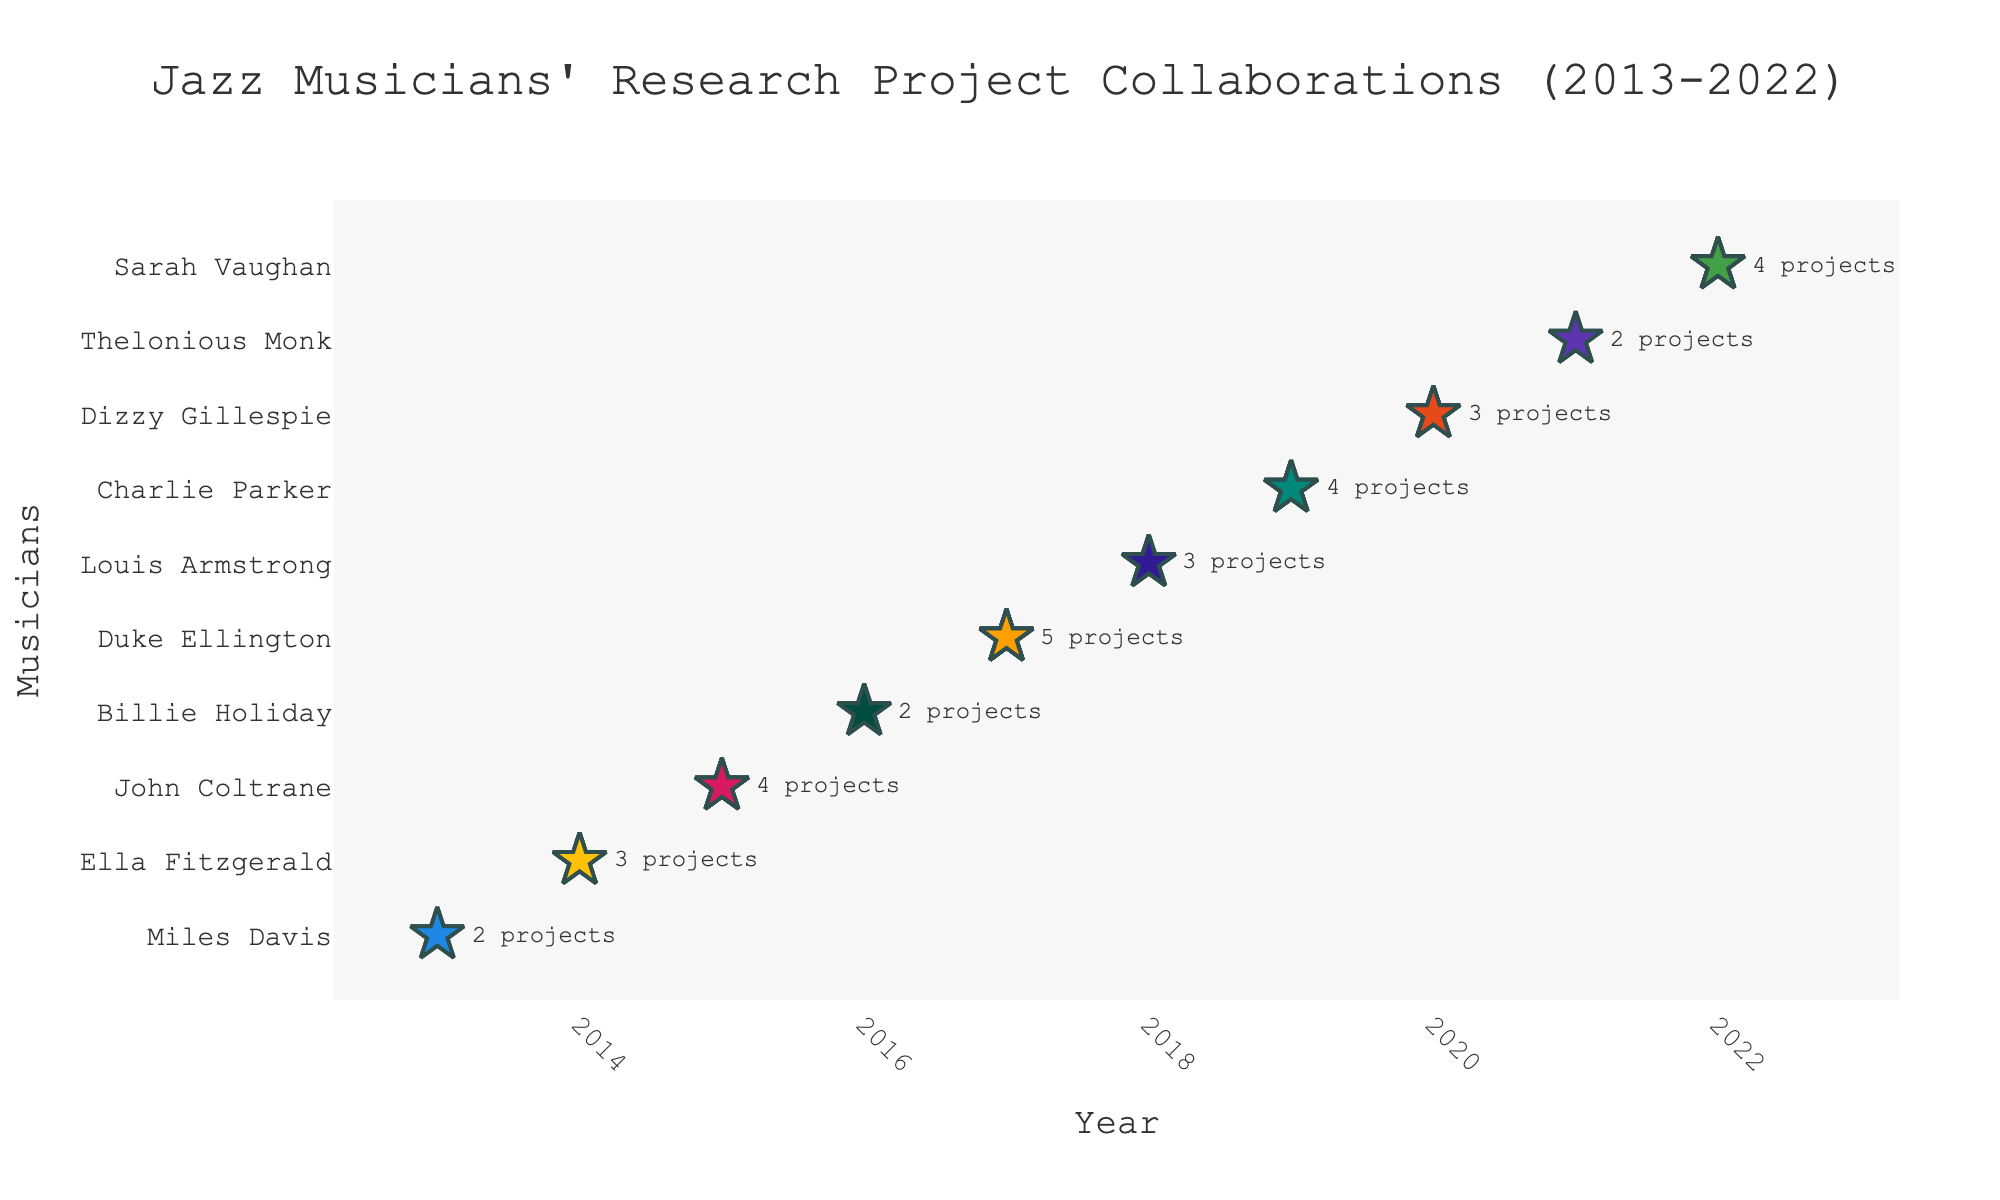What's the title of the plot? The title is displayed at the top of the plot, reading from the figure.
Answer: Jazz Musicians' Research Project Collaborations (2013-2022) Which year had the highest number of research projects? By looking across the years, the year with more stars represents the highest number.
Answer: 2017 How many research projects did Charlie Parker work on in 2019? Find the row corresponding to Charlie Parker and count the number of stars, also cross-referenced with the annotation text.
Answer: 4 Are there any musicians who have worked on exactly three research projects? If so, who are they? Identify the rows with 3 stars and note the names of the musicians and the annotation text.
Answer: Ella Fitzgerald, Louis Armstrong, Dizzy Gillespie How many musicians worked on research projects in 2020? Look at the distribution of stars for the year 2020.
Answer: 1 What’s the average number of research projects per musician per year? Sum the total projects across all musicians and divide by the number of years (summed from annotations: 2+3+4+2+5+3+4+3+2+4=32, then 32/10).
Answer: 3.2 Which musician had the smallest number of research projects? Identify the rows with the minimum number of stars.
Answer: Miles Davis, Billie Holiday, Thelonious Monk Did Sarah Vaughan have more research project collaborations than John Coltrane? Compare the number of stars for each musician.
Answer: Yes How many stars (markers) are there in total on the isotype plot? Sum the number of stars for each year from the annotations.
Answer: 32 What trend do you observe in research projects over the years 2013 to 2022? By observing the overall arrangement and distribution of stars, one can note the pattern.
Answer: Generally varied, with peaks in 2015, 2017, and 2022 